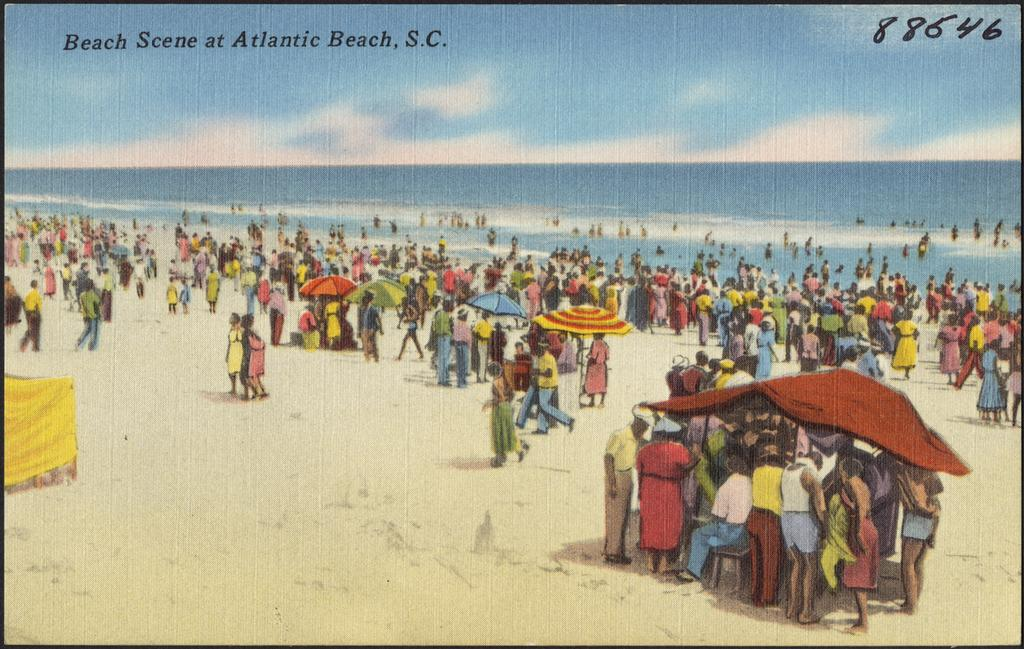<image>
Relay a brief, clear account of the picture shown. Card with people on a beach that has the number 88646 on the top right. 